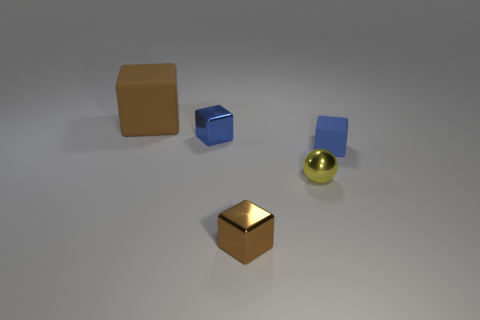Subtract 1 cubes. How many cubes are left? 3 Add 4 blue shiny cubes. How many objects exist? 9 Subtract all spheres. How many objects are left? 4 Subtract all brown matte cylinders. Subtract all small blocks. How many objects are left? 2 Add 1 small brown shiny objects. How many small brown shiny objects are left? 2 Add 1 big purple cylinders. How many big purple cylinders exist? 1 Subtract 0 cyan balls. How many objects are left? 5 